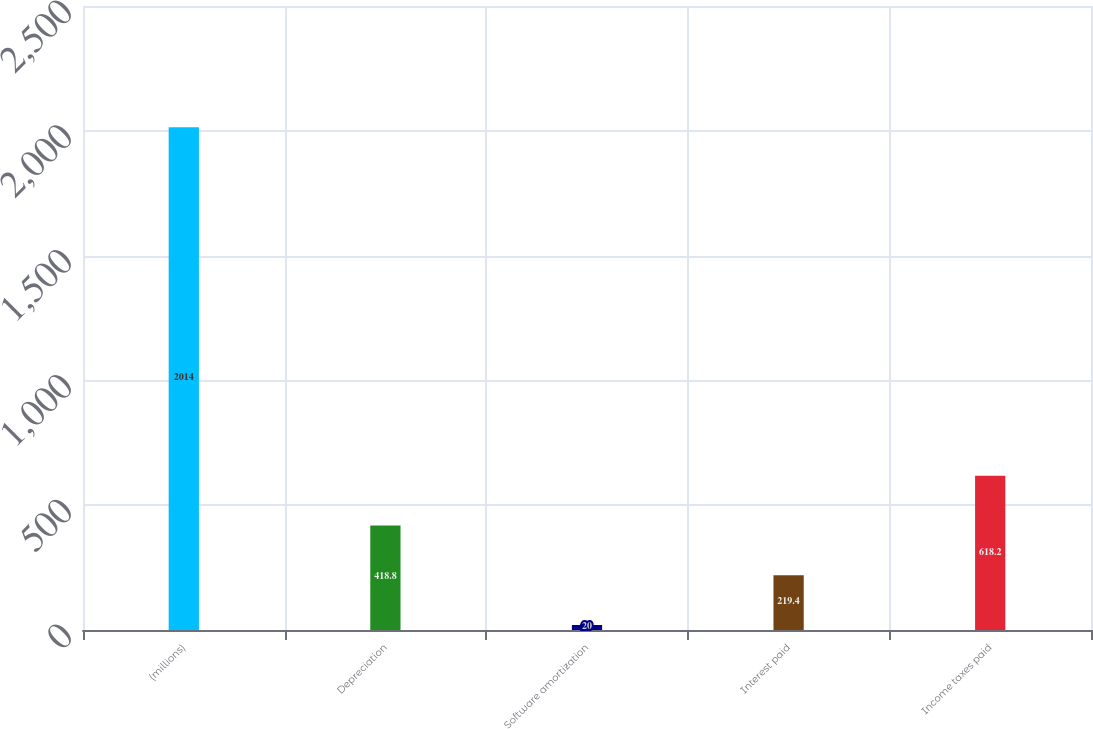Convert chart to OTSL. <chart><loc_0><loc_0><loc_500><loc_500><bar_chart><fcel>(millions)<fcel>Depreciation<fcel>Software amortization<fcel>Interest paid<fcel>Income taxes paid<nl><fcel>2014<fcel>418.8<fcel>20<fcel>219.4<fcel>618.2<nl></chart> 